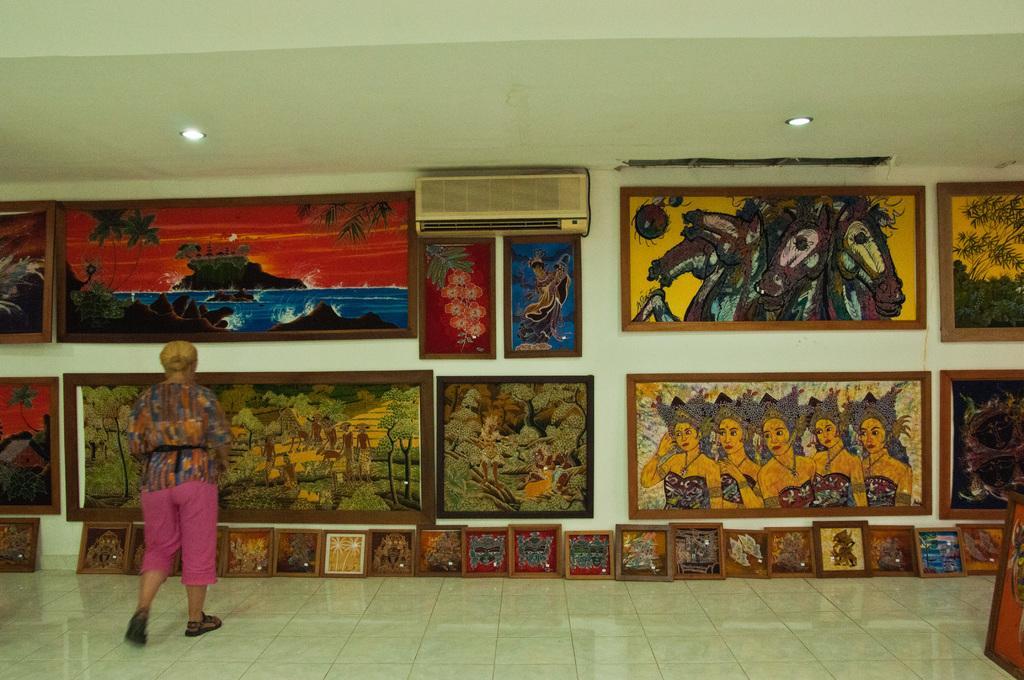Please provide a concise description of this image. In this image, we can see a woman is walking on the floor. Background there is a white wall. Here we can see so many paintings with frame on the wall and floor. Top of the image, there is a ceiling and lights. Here we can see air conditioner. 